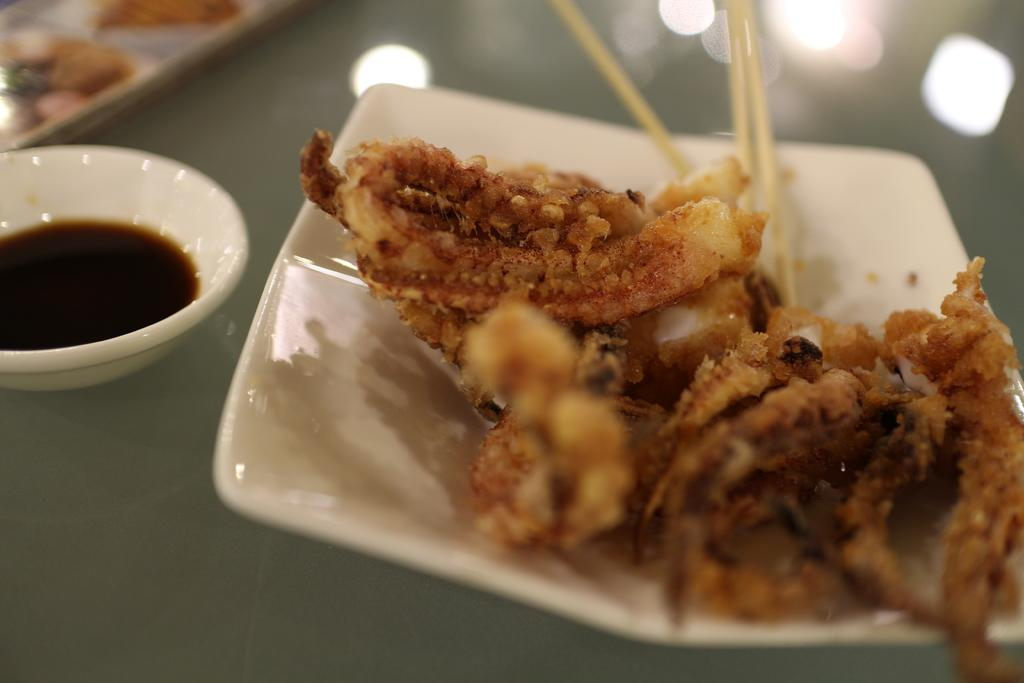What is the main food item visible on the plate in the image? The specific food item cannot be determined from the provided facts. What accompanies the food item on the plate? There is a bowl with sauce beside the plate. What other visual elements can be seen at the top of the image? There are reflections and other objects visible at the top of the image. What type of weather can be seen in the image? The provided facts do not mention any weather-related elements in the image. 